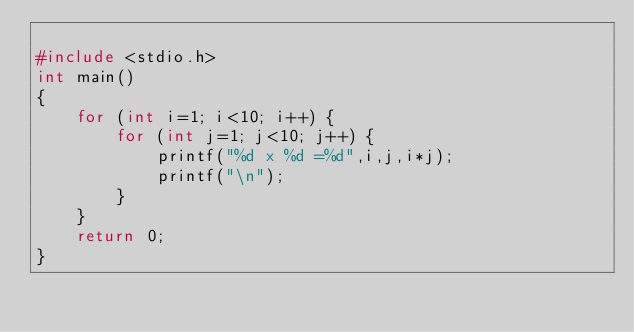Convert code to text. <code><loc_0><loc_0><loc_500><loc_500><_C_>
#include <stdio.h>
int main()
{
    for (int i=1; i<10; i++) {
        for (int j=1; j<10; j++) {
            printf("%d x %d =%d",i,j,i*j);
            printf("\n");
        }
    }
    return 0;
}</code> 